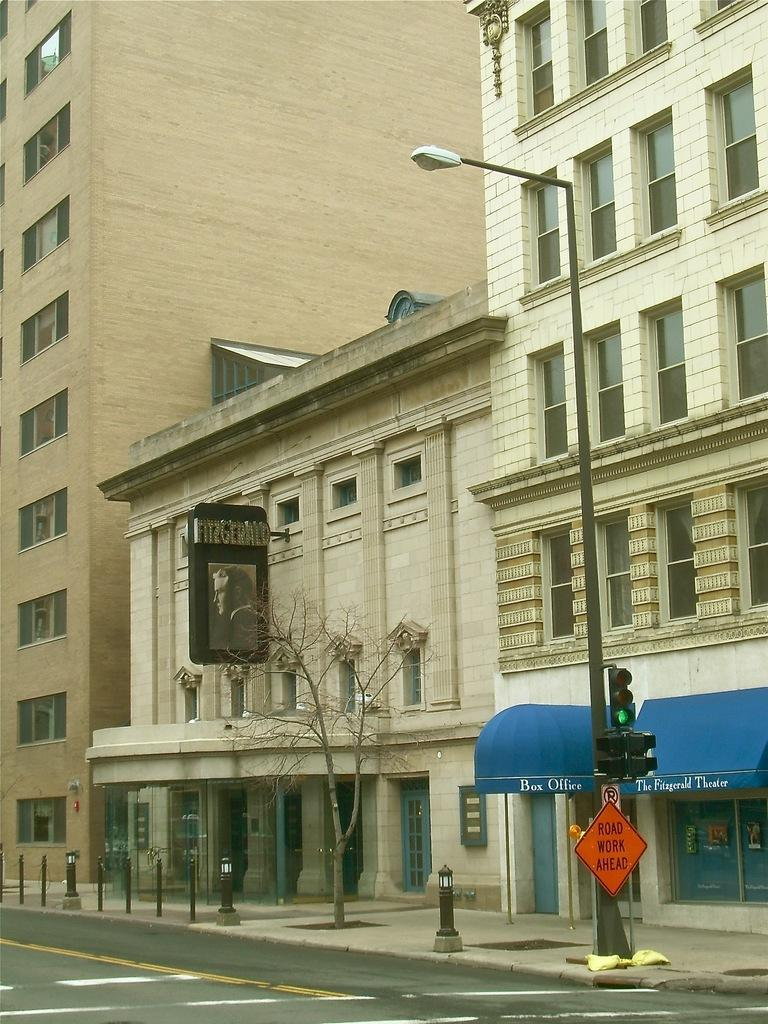What is the color of the building in the image? The building in the image is white. What type of structure is located in front of the building? There is a small shop with a blue canopy shed in front of the building. What utility infrastructure can be seen in the image? An electric pole is visible in the image. What type of traffic control device is present in the image? Signal lights are present in the image. What type of pathway is visible in the image? There is a road in the image. Can you tell me how many rabbits are hopping on the roof of the building in the image? There are no rabbits present in the image, and therefore no such activity can be observed. 